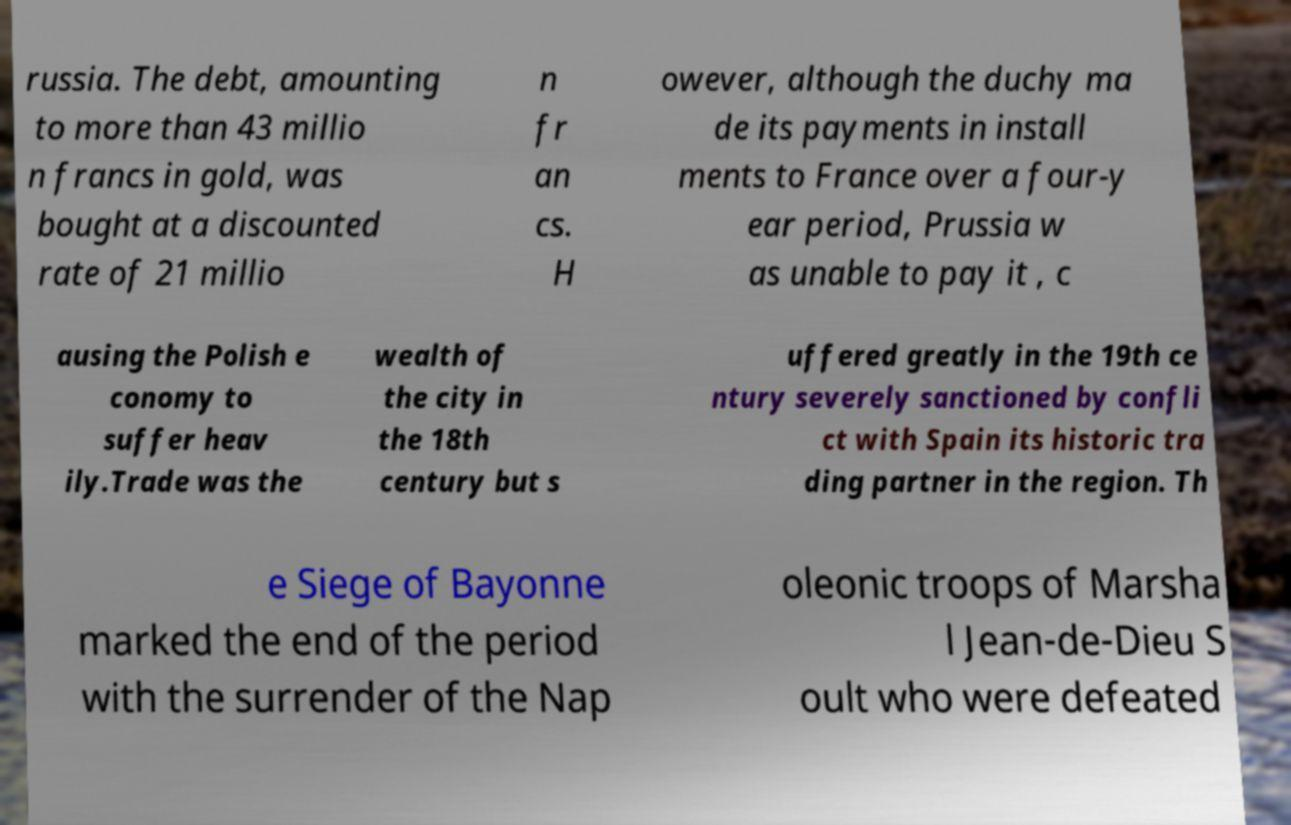Please read and relay the text visible in this image. What does it say? russia. The debt, amounting to more than 43 millio n francs in gold, was bought at a discounted rate of 21 millio n fr an cs. H owever, although the duchy ma de its payments in install ments to France over a four-y ear period, Prussia w as unable to pay it , c ausing the Polish e conomy to suffer heav ily.Trade was the wealth of the city in the 18th century but s uffered greatly in the 19th ce ntury severely sanctioned by confli ct with Spain its historic tra ding partner in the region. Th e Siege of Bayonne marked the end of the period with the surrender of the Nap oleonic troops of Marsha l Jean-de-Dieu S oult who were defeated 